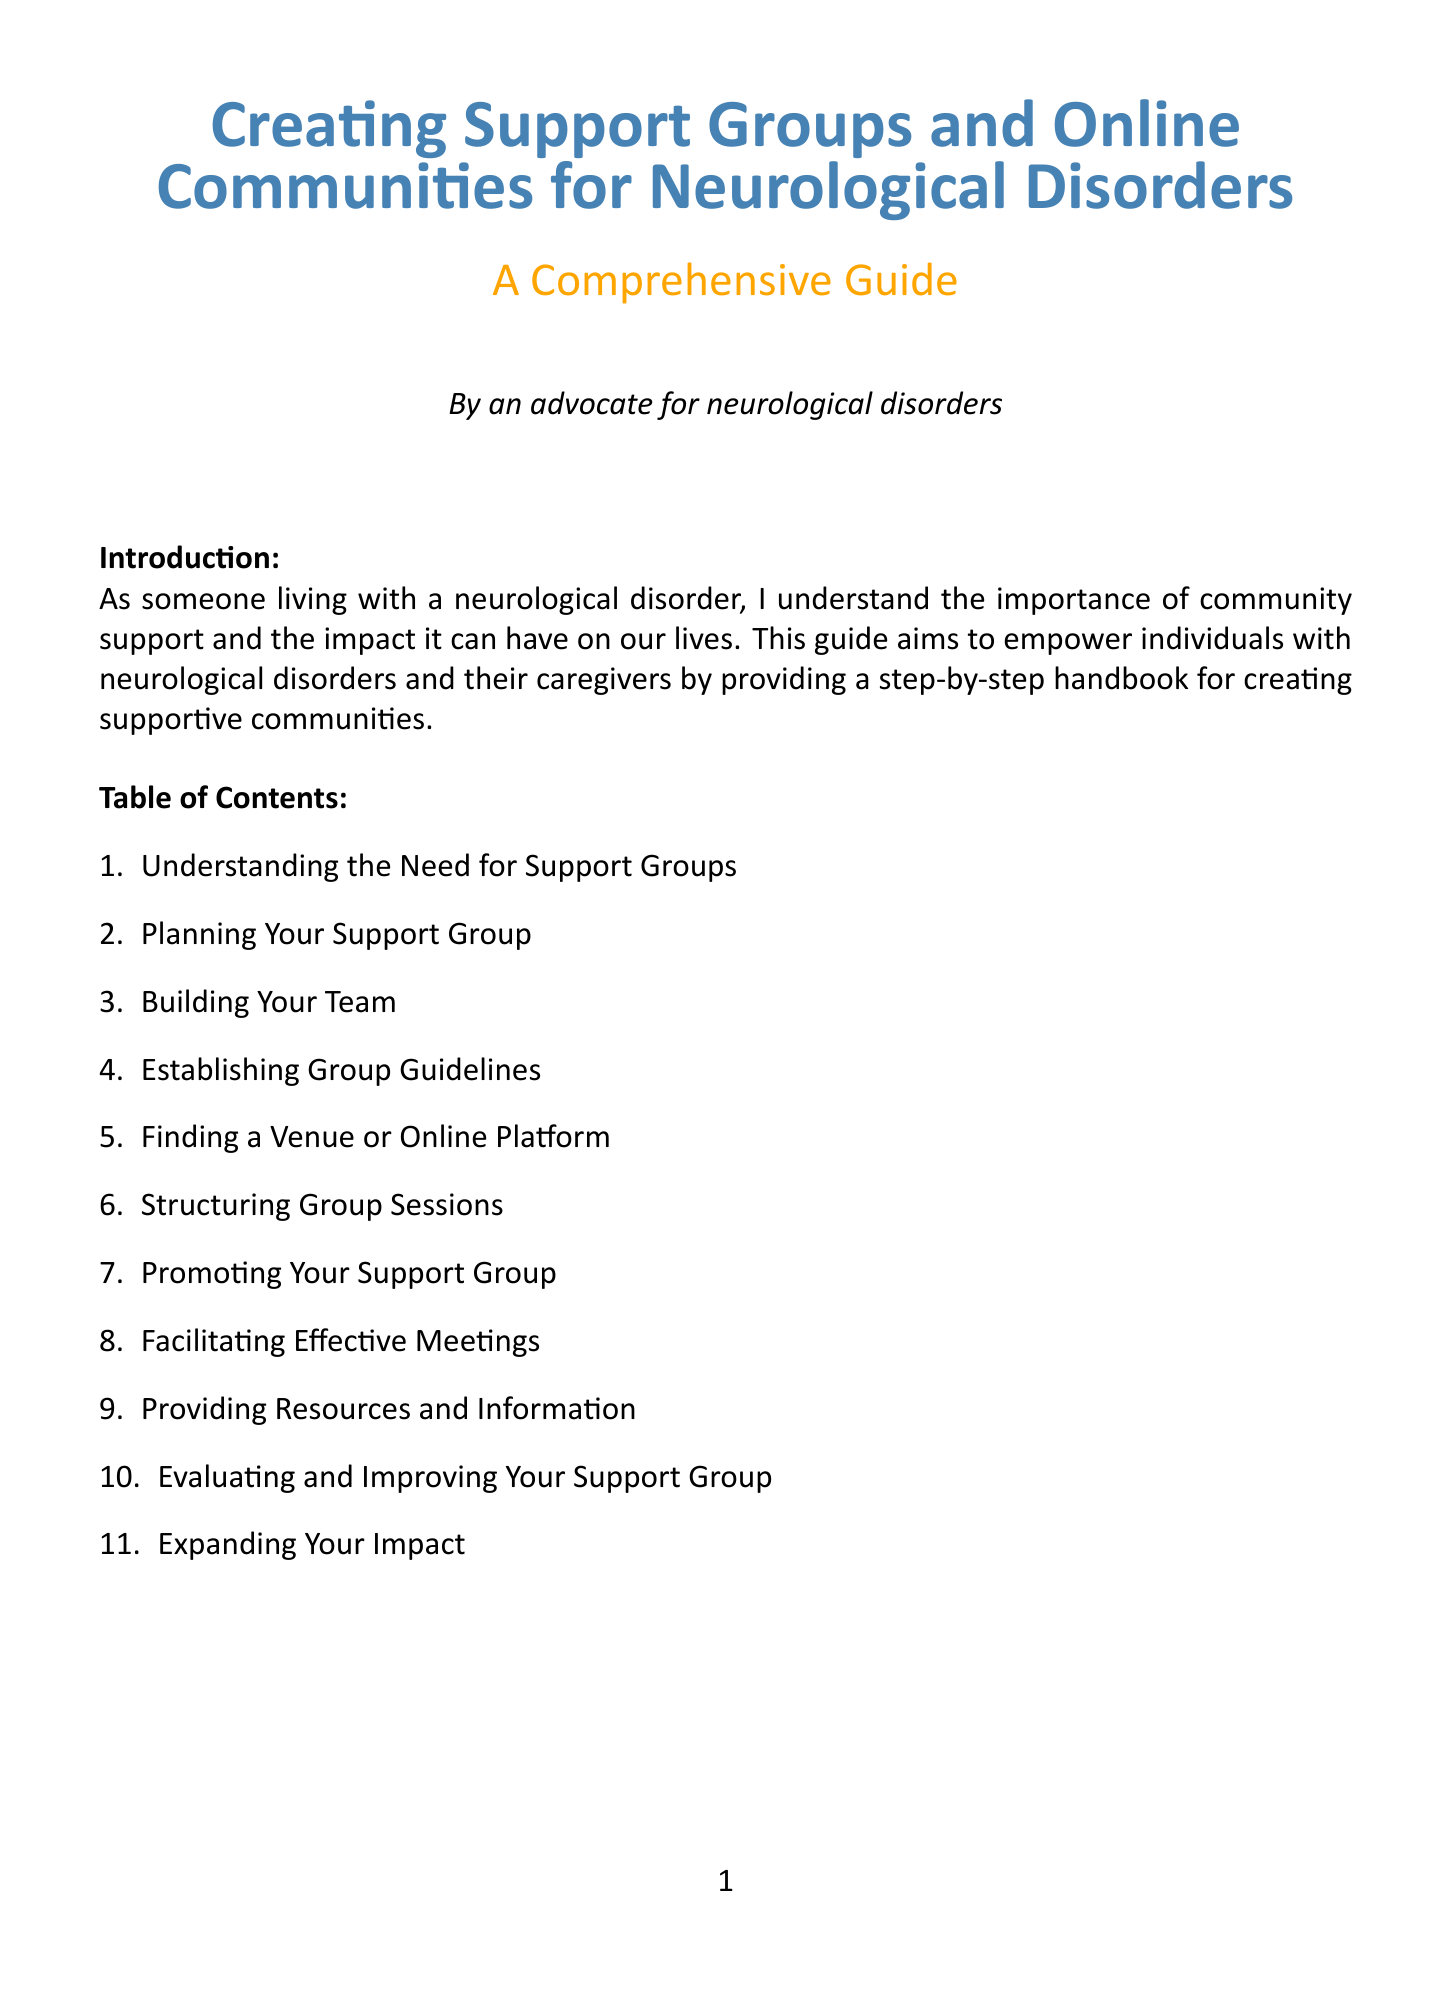What is the purpose of the handbook? The purpose of the handbook is to empower individuals with neurological disorders and their caregivers by providing a step-by-step handbook for creating supportive communities.
Answer: To empower individuals with neurological disorders and their caregivers Who is the author speaking from their perspective? The author speaks from the perspective of someone living with a neurological disorder, emphasizing the importance of community support.
Answer: Someone living with a neurological disorder What types of support groups are mentioned? The document includes in-person, online, and hybrid models as types of support groups.
Answer: In-person, online, and hybrid models What should be identified when planning a support group? Identifying your target audience is a crucial step when planning a support group.
Answer: Target audience How many chapters are there in the handbook? There are eleven chapters in total covering various aspects of creating support groups.
Answer: Eleven chapters What is a role mentioned in "Building Your Team"? Recruiting co-facilitators and volunteers is a specified role in building your team.
Answer: Co-facilitators and volunteers Which online platforms are suggested for finding a venue? Suggested online platforms include Zoom, Facebook Groups, and Discord for finding a venue.
Answer: Zoom, Facebook Groups, Discord What is a method for promoting the support group? Utilizing social media and online directories is mentioned as a promotion method for the support group.
Answer: Social media and online directories What is included in the appendices? The appendices include sample forms and templates and useful resources for further assistance.
Answer: Sample forms and templates, useful resources 